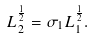<formula> <loc_0><loc_0><loc_500><loc_500>L _ { 2 } ^ { \frac { 1 } { 2 } } = \sigma _ { 1 } L _ { 1 } ^ { \frac { 1 } { 2 } } .</formula> 